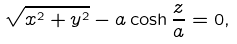<formula> <loc_0><loc_0><loc_500><loc_500>\sqrt { x ^ { 2 } + y ^ { 2 } } - a \cosh \frac { z } { a } = 0 ,</formula> 